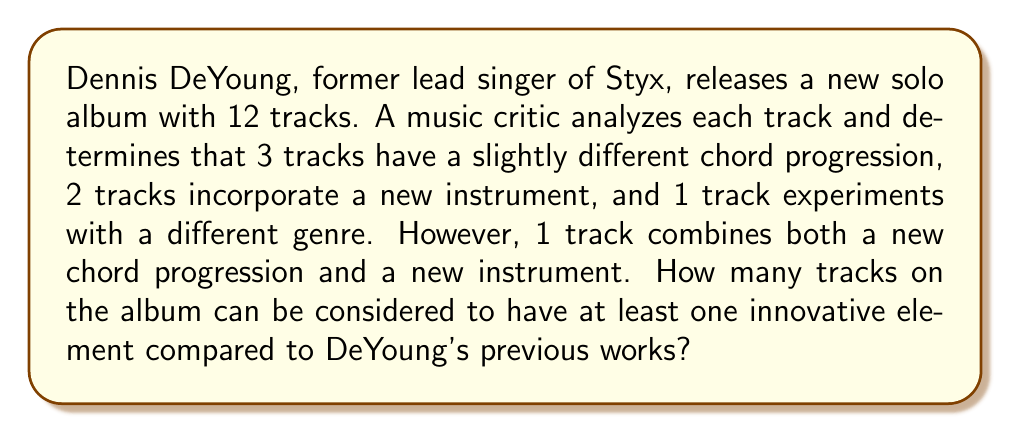What is the answer to this math problem? Let's approach this step-by-step using the principle of inclusion-exclusion:

1) Let A be the set of tracks with a different chord progression
2) Let B be the set of tracks with a new instrument
3) Let C be the set of tracks experimenting with a different genre

We know:
$|A| = 3$
$|B| = 2$
$|C| = 1$
$|A \cap B| = 1$ (the track that combines new chord progression and new instrument)
$|A \cap C| = |B \cap C| = |A \cap B \cap C| = 0$ (assumed, as not mentioned in the question)

The total number of innovative tracks is:

$$|A \cup B \cup C| = |A| + |B| + |C| - |A \cap B| - |A \cap C| - |B \cap C| + |A \cap B \cap C|$$

Substituting the values:

$$|A \cup B \cup C| = 3 + 2 + 1 - 1 - 0 - 0 + 0 = 5$$

Therefore, 5 tracks on the album can be considered to have at least one innovative element.
Answer: 5 tracks 